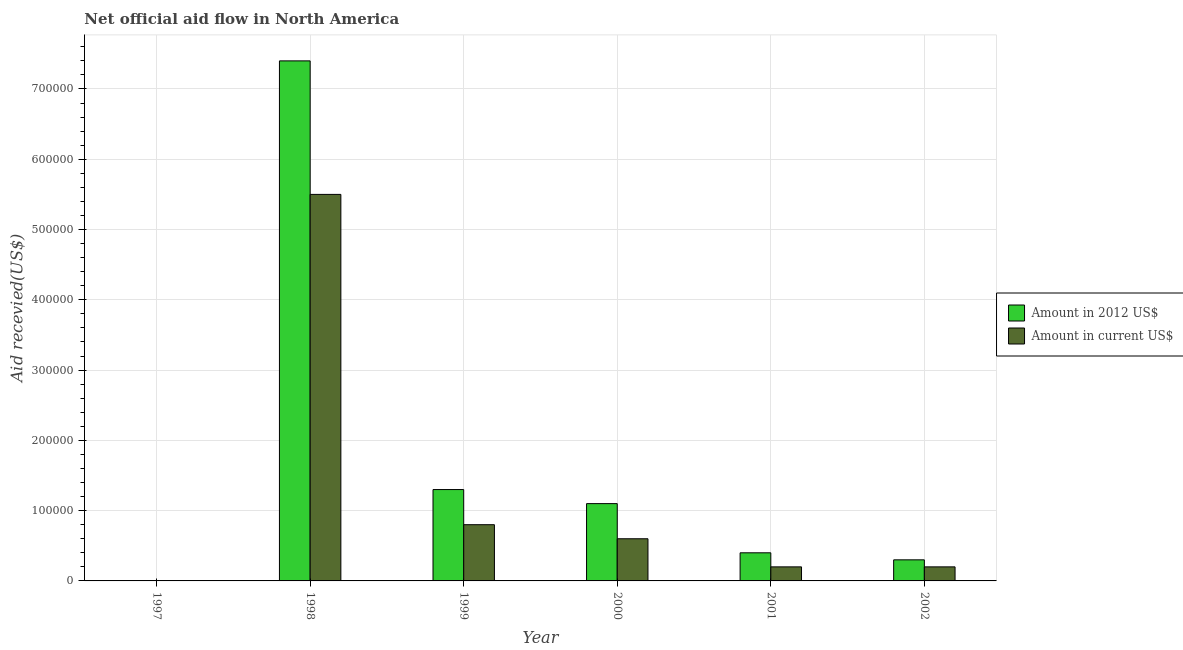Are the number of bars per tick equal to the number of legend labels?
Your answer should be compact. No. Are the number of bars on each tick of the X-axis equal?
Your answer should be very brief. No. How many bars are there on the 4th tick from the left?
Offer a terse response. 2. How many bars are there on the 1st tick from the right?
Offer a very short reply. 2. What is the label of the 2nd group of bars from the left?
Make the answer very short. 1998. What is the amount of aid received(expressed in 2012 us$) in 2001?
Keep it short and to the point. 4.00e+04. Across all years, what is the maximum amount of aid received(expressed in us$)?
Offer a terse response. 5.50e+05. In which year was the amount of aid received(expressed in us$) maximum?
Provide a succinct answer. 1998. What is the total amount of aid received(expressed in 2012 us$) in the graph?
Ensure brevity in your answer.  1.05e+06. What is the difference between the amount of aid received(expressed in us$) in 2000 and that in 2001?
Your response must be concise. 4.00e+04. What is the difference between the amount of aid received(expressed in 2012 us$) in 2000 and the amount of aid received(expressed in us$) in 1997?
Ensure brevity in your answer.  1.10e+05. What is the average amount of aid received(expressed in us$) per year?
Provide a succinct answer. 1.22e+05. In the year 1999, what is the difference between the amount of aid received(expressed in us$) and amount of aid received(expressed in 2012 us$)?
Provide a succinct answer. 0. What is the ratio of the amount of aid received(expressed in us$) in 1998 to that in 2001?
Give a very brief answer. 27.5. Is the amount of aid received(expressed in 2012 us$) in 2000 less than that in 2002?
Make the answer very short. No. Is the difference between the amount of aid received(expressed in us$) in 1998 and 2001 greater than the difference between the amount of aid received(expressed in 2012 us$) in 1998 and 2001?
Your answer should be compact. No. What is the difference between the highest and the lowest amount of aid received(expressed in us$)?
Your response must be concise. 5.50e+05. Are all the bars in the graph horizontal?
Offer a terse response. No. How many years are there in the graph?
Your response must be concise. 6. What is the difference between two consecutive major ticks on the Y-axis?
Offer a terse response. 1.00e+05. Are the values on the major ticks of Y-axis written in scientific E-notation?
Offer a terse response. No. Where does the legend appear in the graph?
Your answer should be very brief. Center right. What is the title of the graph?
Make the answer very short. Net official aid flow in North America. Does "Private consumption" appear as one of the legend labels in the graph?
Offer a very short reply. No. What is the label or title of the X-axis?
Make the answer very short. Year. What is the label or title of the Y-axis?
Offer a very short reply. Aid recevied(US$). What is the Aid recevied(US$) in Amount in current US$ in 1997?
Offer a very short reply. 0. What is the Aid recevied(US$) of Amount in 2012 US$ in 1998?
Offer a terse response. 7.40e+05. What is the Aid recevied(US$) in Amount in current US$ in 1998?
Provide a short and direct response. 5.50e+05. What is the Aid recevied(US$) in Amount in current US$ in 1999?
Ensure brevity in your answer.  8.00e+04. What is the Aid recevied(US$) in Amount in 2012 US$ in 2002?
Offer a very short reply. 3.00e+04. Across all years, what is the maximum Aid recevied(US$) of Amount in 2012 US$?
Offer a terse response. 7.40e+05. Across all years, what is the maximum Aid recevied(US$) in Amount in current US$?
Offer a very short reply. 5.50e+05. Across all years, what is the minimum Aid recevied(US$) in Amount in 2012 US$?
Provide a short and direct response. 0. What is the total Aid recevied(US$) in Amount in 2012 US$ in the graph?
Ensure brevity in your answer.  1.05e+06. What is the total Aid recevied(US$) of Amount in current US$ in the graph?
Offer a terse response. 7.30e+05. What is the difference between the Aid recevied(US$) of Amount in 2012 US$ in 1998 and that in 1999?
Your response must be concise. 6.10e+05. What is the difference between the Aid recevied(US$) in Amount in 2012 US$ in 1998 and that in 2000?
Offer a very short reply. 6.30e+05. What is the difference between the Aid recevied(US$) of Amount in current US$ in 1998 and that in 2001?
Offer a terse response. 5.30e+05. What is the difference between the Aid recevied(US$) in Amount in 2012 US$ in 1998 and that in 2002?
Keep it short and to the point. 7.10e+05. What is the difference between the Aid recevied(US$) in Amount in current US$ in 1998 and that in 2002?
Give a very brief answer. 5.30e+05. What is the difference between the Aid recevied(US$) of Amount in current US$ in 1999 and that in 2000?
Offer a terse response. 2.00e+04. What is the difference between the Aid recevied(US$) of Amount in current US$ in 1999 and that in 2001?
Give a very brief answer. 6.00e+04. What is the difference between the Aid recevied(US$) of Amount in 2012 US$ in 1999 and that in 2002?
Provide a short and direct response. 1.00e+05. What is the difference between the Aid recevied(US$) of Amount in current US$ in 1999 and that in 2002?
Offer a terse response. 6.00e+04. What is the difference between the Aid recevied(US$) in Amount in current US$ in 2000 and that in 2001?
Give a very brief answer. 4.00e+04. What is the difference between the Aid recevied(US$) in Amount in 2012 US$ in 2000 and that in 2002?
Your response must be concise. 8.00e+04. What is the difference between the Aid recevied(US$) in Amount in 2012 US$ in 1998 and the Aid recevied(US$) in Amount in current US$ in 2000?
Give a very brief answer. 6.80e+05. What is the difference between the Aid recevied(US$) in Amount in 2012 US$ in 1998 and the Aid recevied(US$) in Amount in current US$ in 2001?
Your response must be concise. 7.20e+05. What is the difference between the Aid recevied(US$) of Amount in 2012 US$ in 1998 and the Aid recevied(US$) of Amount in current US$ in 2002?
Your answer should be compact. 7.20e+05. What is the difference between the Aid recevied(US$) in Amount in 2012 US$ in 2000 and the Aid recevied(US$) in Amount in current US$ in 2001?
Your answer should be very brief. 9.00e+04. What is the difference between the Aid recevied(US$) of Amount in 2012 US$ in 2000 and the Aid recevied(US$) of Amount in current US$ in 2002?
Make the answer very short. 9.00e+04. What is the difference between the Aid recevied(US$) in Amount in 2012 US$ in 2001 and the Aid recevied(US$) in Amount in current US$ in 2002?
Offer a very short reply. 2.00e+04. What is the average Aid recevied(US$) of Amount in 2012 US$ per year?
Provide a succinct answer. 1.75e+05. What is the average Aid recevied(US$) in Amount in current US$ per year?
Your answer should be compact. 1.22e+05. In the year 1999, what is the difference between the Aid recevied(US$) in Amount in 2012 US$ and Aid recevied(US$) in Amount in current US$?
Provide a succinct answer. 5.00e+04. In the year 2001, what is the difference between the Aid recevied(US$) in Amount in 2012 US$ and Aid recevied(US$) in Amount in current US$?
Offer a terse response. 2.00e+04. In the year 2002, what is the difference between the Aid recevied(US$) in Amount in 2012 US$ and Aid recevied(US$) in Amount in current US$?
Your answer should be very brief. 10000. What is the ratio of the Aid recevied(US$) of Amount in 2012 US$ in 1998 to that in 1999?
Your answer should be compact. 5.69. What is the ratio of the Aid recevied(US$) of Amount in current US$ in 1998 to that in 1999?
Provide a short and direct response. 6.88. What is the ratio of the Aid recevied(US$) in Amount in 2012 US$ in 1998 to that in 2000?
Keep it short and to the point. 6.73. What is the ratio of the Aid recevied(US$) in Amount in current US$ in 1998 to that in 2000?
Your answer should be very brief. 9.17. What is the ratio of the Aid recevied(US$) in Amount in 2012 US$ in 1998 to that in 2001?
Your answer should be very brief. 18.5. What is the ratio of the Aid recevied(US$) of Amount in 2012 US$ in 1998 to that in 2002?
Offer a very short reply. 24.67. What is the ratio of the Aid recevied(US$) in Amount in current US$ in 1998 to that in 2002?
Make the answer very short. 27.5. What is the ratio of the Aid recevied(US$) in Amount in 2012 US$ in 1999 to that in 2000?
Your response must be concise. 1.18. What is the ratio of the Aid recevied(US$) of Amount in 2012 US$ in 1999 to that in 2001?
Provide a succinct answer. 3.25. What is the ratio of the Aid recevied(US$) in Amount in 2012 US$ in 1999 to that in 2002?
Ensure brevity in your answer.  4.33. What is the ratio of the Aid recevied(US$) of Amount in current US$ in 1999 to that in 2002?
Offer a very short reply. 4. What is the ratio of the Aid recevied(US$) of Amount in 2012 US$ in 2000 to that in 2001?
Your answer should be very brief. 2.75. What is the ratio of the Aid recevied(US$) in Amount in 2012 US$ in 2000 to that in 2002?
Make the answer very short. 3.67. What is the ratio of the Aid recevied(US$) in Amount in current US$ in 2000 to that in 2002?
Keep it short and to the point. 3. What is the ratio of the Aid recevied(US$) of Amount in current US$ in 2001 to that in 2002?
Provide a succinct answer. 1. What is the difference between the highest and the second highest Aid recevied(US$) of Amount in 2012 US$?
Keep it short and to the point. 6.10e+05. What is the difference between the highest and the second highest Aid recevied(US$) in Amount in current US$?
Your answer should be compact. 4.70e+05. What is the difference between the highest and the lowest Aid recevied(US$) in Amount in 2012 US$?
Your answer should be compact. 7.40e+05. 